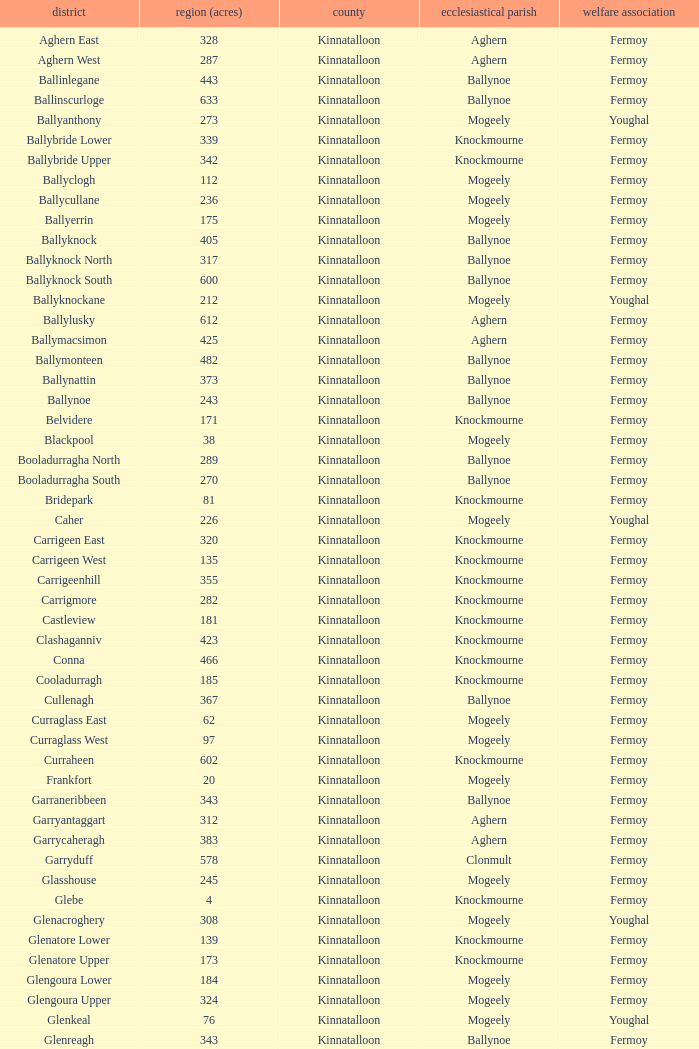Name the area for civil parish ballynoe and killasseragh 340.0. 